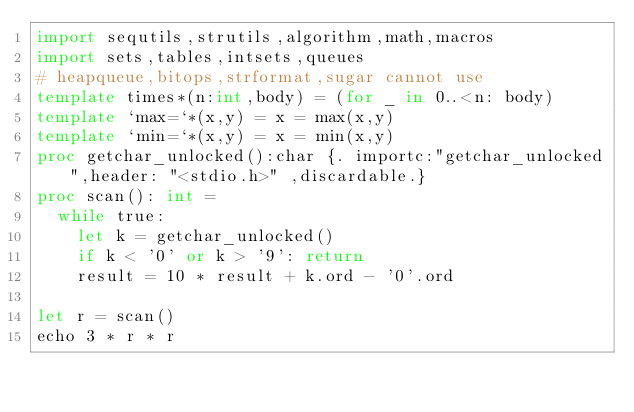<code> <loc_0><loc_0><loc_500><loc_500><_Nim_>import sequtils,strutils,algorithm,math,macros
import sets,tables,intsets,queues
# heapqueue,bitops,strformat,sugar cannot use
template times*(n:int,body) = (for _ in 0..<n: body)
template `max=`*(x,y) = x = max(x,y)
template `min=`*(x,y) = x = min(x,y)
proc getchar_unlocked():char {. importc:"getchar_unlocked",header: "<stdio.h>" ,discardable.}
proc scan(): int =
  while true:
    let k = getchar_unlocked()
    if k < '0' or k > '9': return
    result = 10 * result + k.ord - '0'.ord

let r = scan()
echo 3 * r * r
</code> 